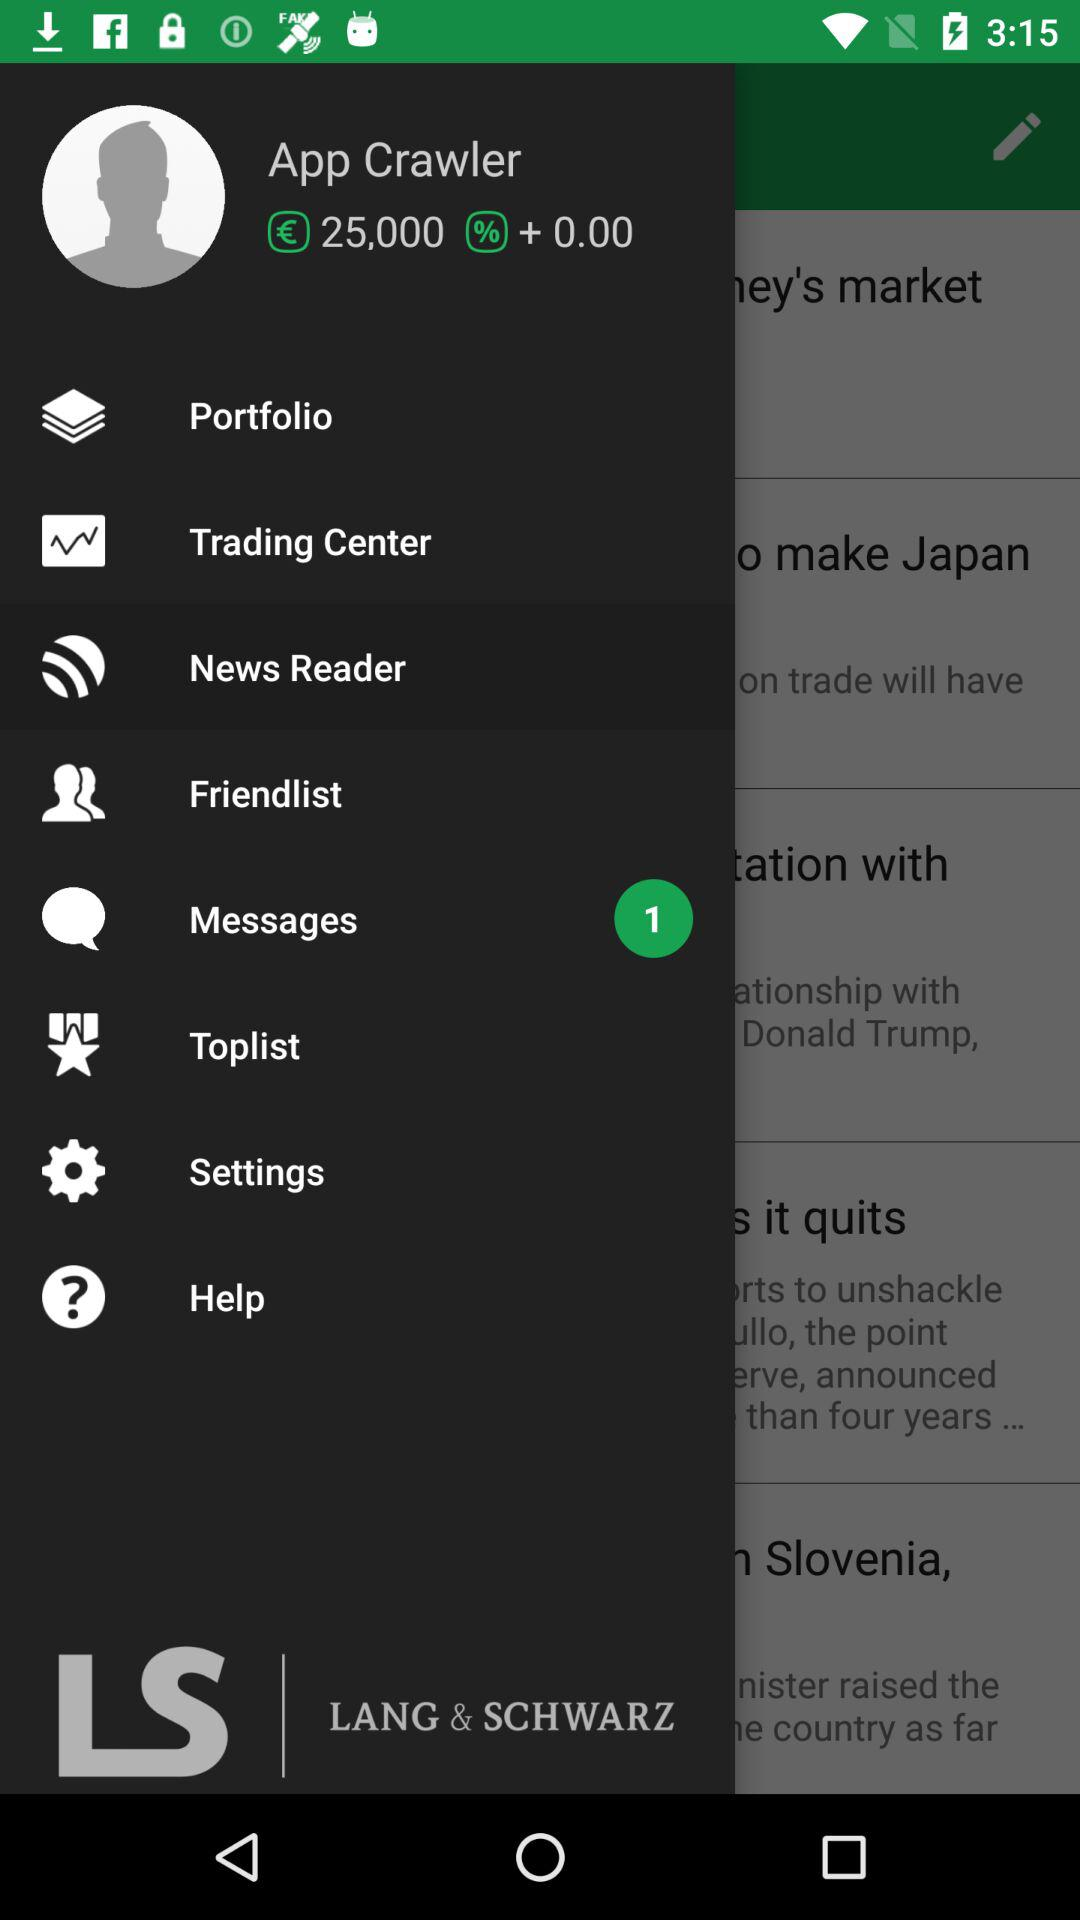What is the name of the user? The name of the user App Crawler. 